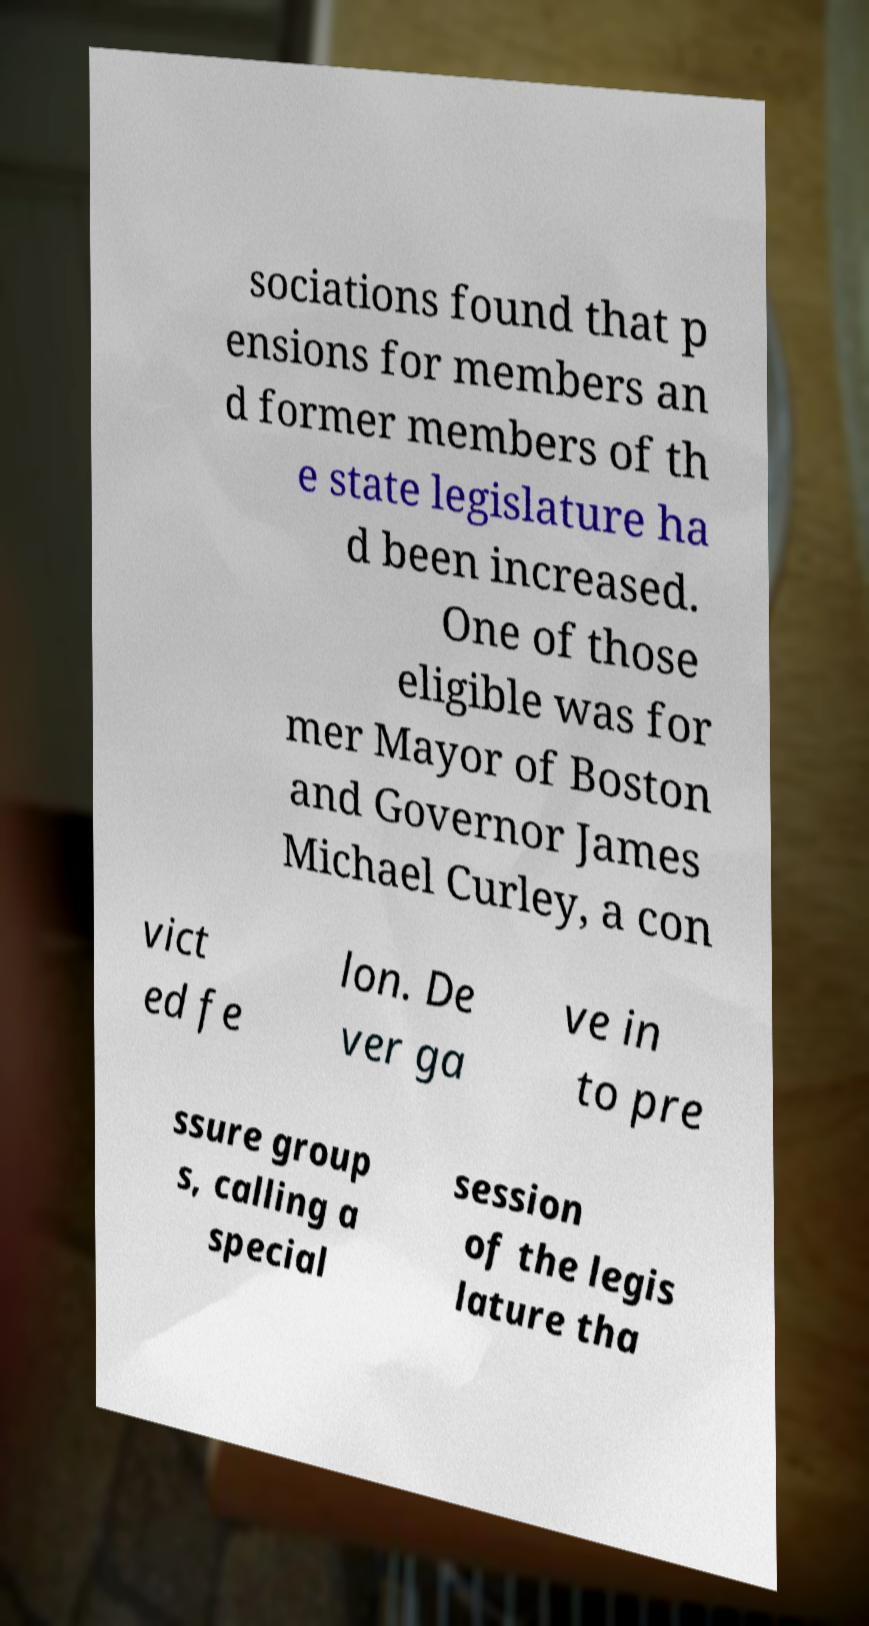Please read and relay the text visible in this image. What does it say? sociations found that p ensions for members an d former members of th e state legislature ha d been increased. One of those eligible was for mer Mayor of Boston and Governor James Michael Curley, a con vict ed fe lon. De ver ga ve in to pre ssure group s, calling a special session of the legis lature tha 